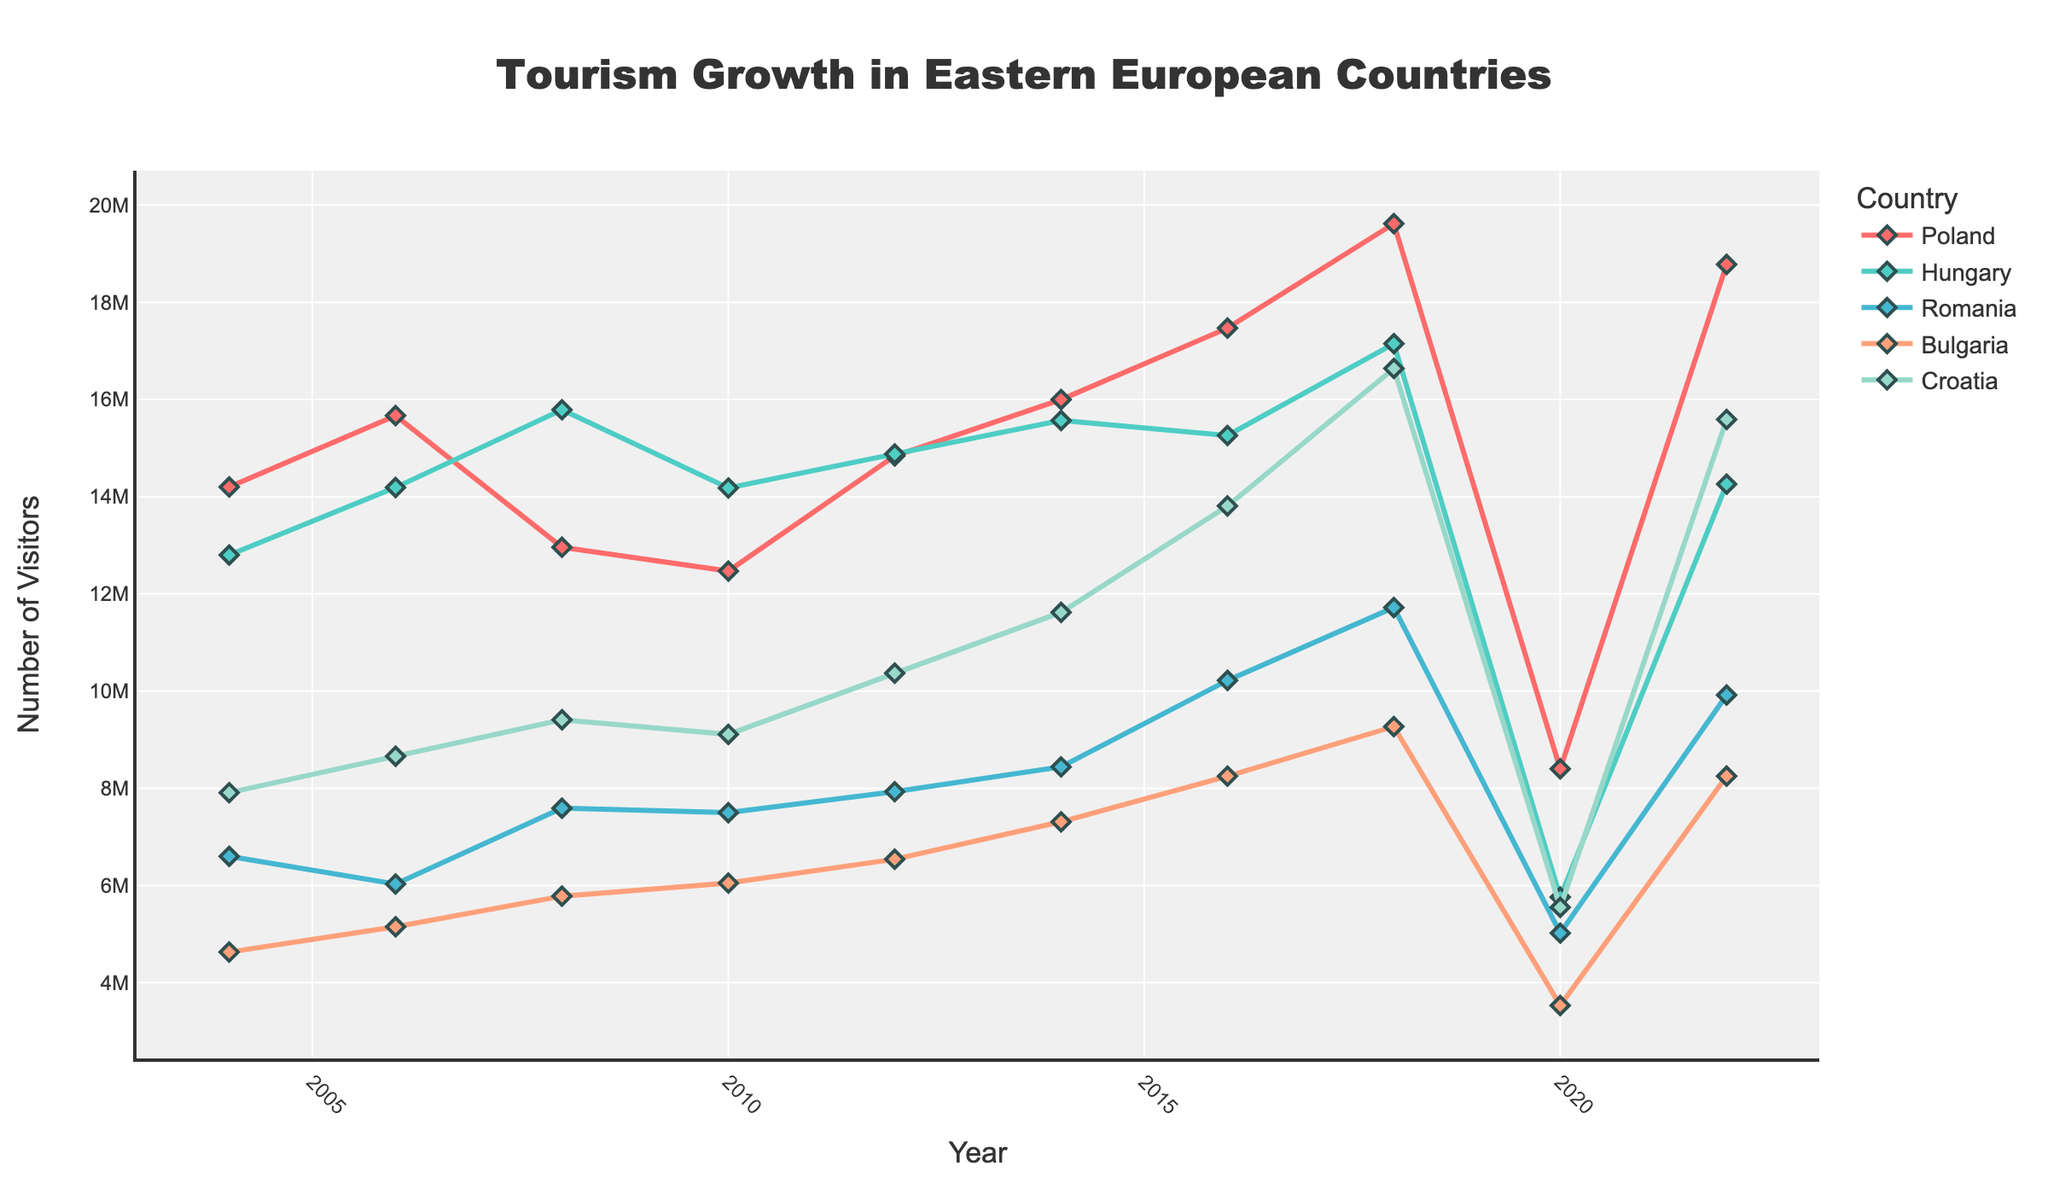Which country had the highest number of visitors in 2018? To find the country with the highest visitors in 2018, locate the points on the lines that correspond to the year 2018 and compare their values. Croatia has the highest value in 2018.
Answer: Croatia How did the number of visitors to Poland change from 2010 to 2016? Locate the data points for Poland in 2010 and 2016. Note the values: 12,470,000 in 2010 and 17,470,000 in 2016. Subtract the earlier value from the later value to find the change: 17,470,000 - 12,470,000.
Answer: Increased by 5,000,000 Between 2004 and 2022, which country saw the least percentage decline in visitors in 2020? Compare the relative drop in visitors from 2018 to 2020 for each of the five countries. Calculate the percentage decline for each country and determine the least decline. Poland shows the least relative drop.
Answer: Poland Which two countries have almost the same number of visitors in 2022? Look at the endpoints on the line chart for the year 2022 and compare their values. Bulgaria and Romania have visitor counts that are very close to each other.
Answer: Bulgaria and Romania What was the trend in the number of visitors to Hungary between 2018 and 2022? Observe the slope of the line for Hungary between 2018 and 2022. The value drops from 17,150,000 in 2018 to 14,260,000 in 2022.
Answer: Decreased How many more visitors did Croatia have in 2016 compared to 2006? Compare visitor numbers for Croatia in 2016 and 2006. Calculate the difference: 13,810,000 (2016) - 8,660,000 (2006).
Answer: 5,150,000 more visitors In which year did Romania experience the highest number of visitors? Locate the peak point in Romania's line and identify the year. The highest point is in 2018 with 11,720,000 visitors.
Answer: 2018 Which country had the smallest visitor count in 2020? Examine the lines for 2020 and identify the lowest point. Bulgaria has the smallest visitor count in 2020, at 3,530,000.
Answer: Bulgaria What is the overall trend of tourism growth in Poland from 2004 to 2022? Look at the general direction of Poland’s line from 2004 to 2022. Despite fluctuations, the overall trend is an increase in tourism numbers.
Answer: Increasing 